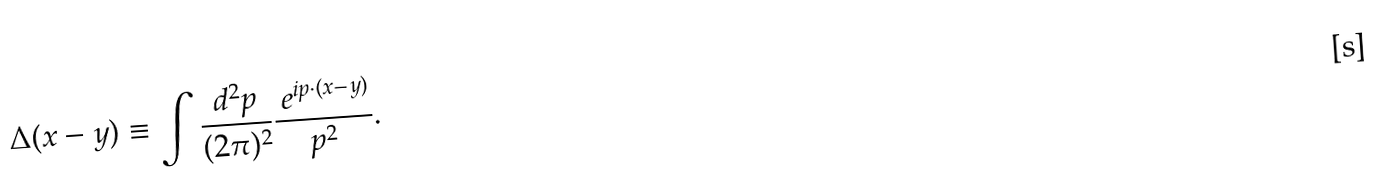<formula> <loc_0><loc_0><loc_500><loc_500>\Delta ( x - y ) \equiv \int \frac { d ^ { 2 } p } { ( 2 \pi ) ^ { 2 } } \frac { \ e ^ { i p \cdot ( x - y ) } } { p ^ { 2 } } .</formula> 